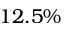Convert formula to latex. <formula><loc_0><loc_0><loc_500><loc_500>1 2 . 5 \%</formula> 